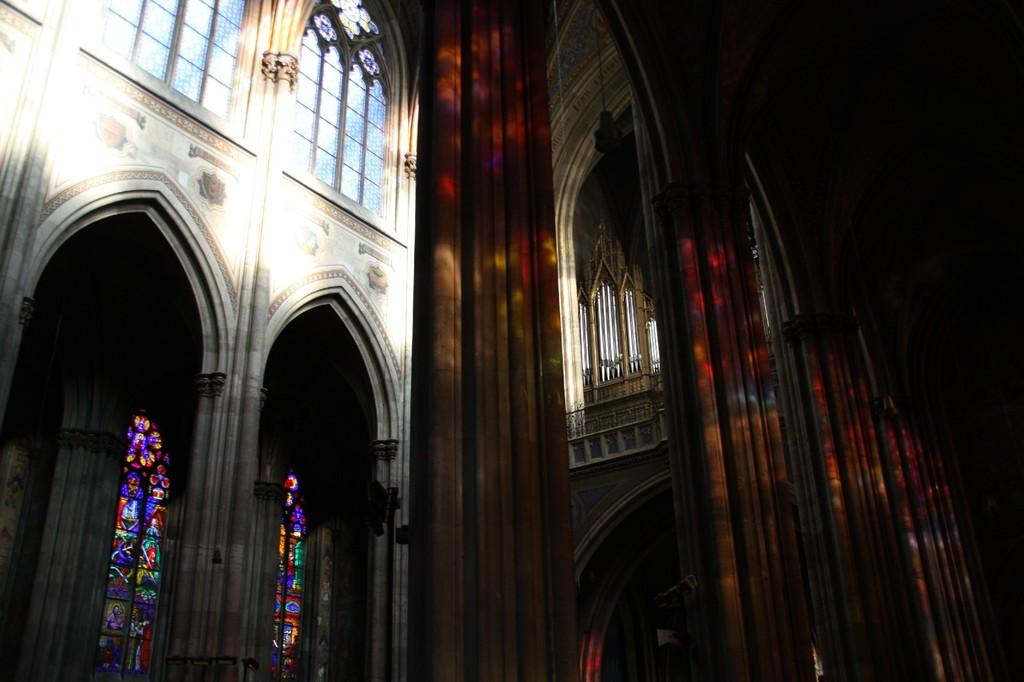What type of structures are present in the image? There are buildings in the image. What feature do the buildings have? The buildings have windows. What is displayed on the windows of the buildings? There are paintings on the windows. What type of stitch is used to create the paintings on the windows? There is no mention of stitching or any specific technique used to create the paintings on the windows in the image. 